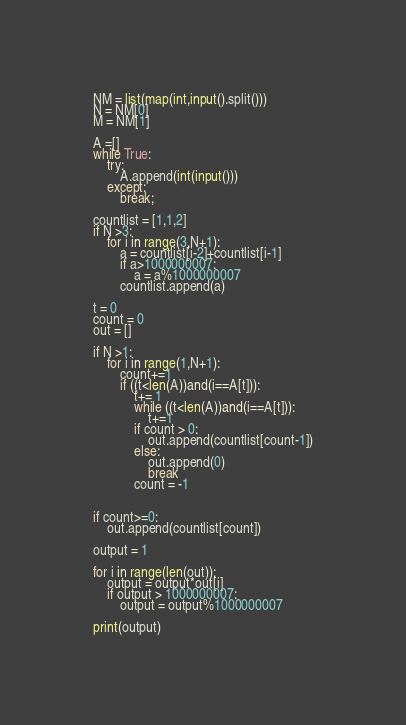Convert code to text. <code><loc_0><loc_0><loc_500><loc_500><_Python_>NM = list(map(int,input().split()))
N = NM[0]
M = NM[1]

A =[]
while True:
    try:
        A.append(int(input()))
    except:
        break;

countlist = [1,1,2]
if N >3:
    for i in range(3,N+1):
        a = countlist[i-2]+countlist[i-1]
        if a>1000000007:
            a = a%1000000007
        countlist.append(a)

t = 0
count = 0
out = []

if N >1:
    for i in range(1,N+1):
        count+=1
        if ((t<len(A))and(i==A[t])):
            t+= 1
            while ((t<len(A))and(i==A[t])):
                t+=1
            if count > 0:
                out.append(countlist[count-1])
            else:
                out.append(0)
                break
            count = -1


if count>=0:
    out.append(countlist[count])

output = 1

for i in range(len(out)):
    output = output*out[i]
    if output > 1000000007:
        output = output%1000000007

print(output)</code> 